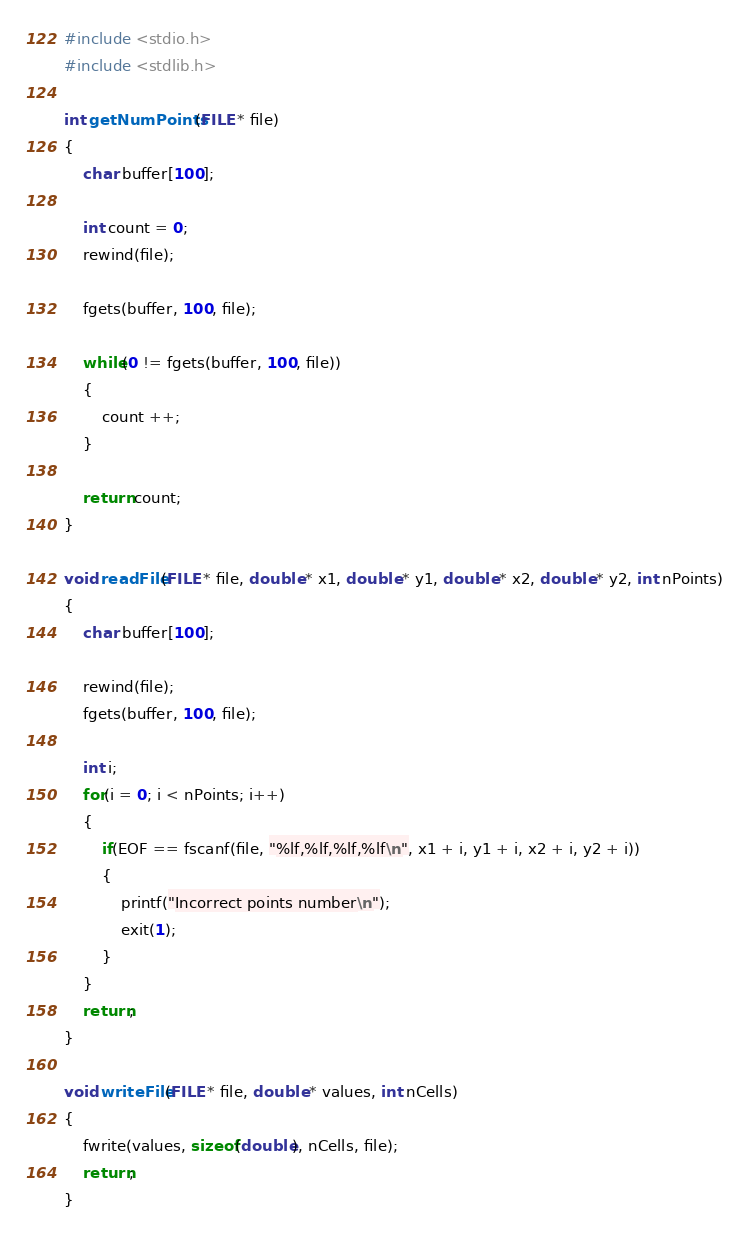<code> <loc_0><loc_0><loc_500><loc_500><_C_>#include <stdio.h>
#include <stdlib.h>

int getNumPoints(FILE * file)
{
	char buffer[100];
	
	int count = 0;
	rewind(file);

	fgets(buffer, 100, file);

	while(0 != fgets(buffer, 100, file))
	{
		count ++;
	}

	return count;
}

void readFile(FILE * file, double * x1, double * y1, double * x2, double * y2, int nPoints)
{
	char buffer[100];

	rewind(file);
	fgets(buffer, 100, file);

	int i;	
	for(i = 0; i < nPoints; i++)
	{
		if(EOF == fscanf(file, "%lf,%lf,%lf,%lf\n", x1 + i, y1 + i, x2 + i, y2 + i))
		{
			printf("Incorrect points number\n");
			exit(1);
		}
	}
	return;
}

void writeFile(FILE * file, double * values, int nCells)
{	
	fwrite(values, sizeof(double), nCells, file);
	return;
} 
</code> 